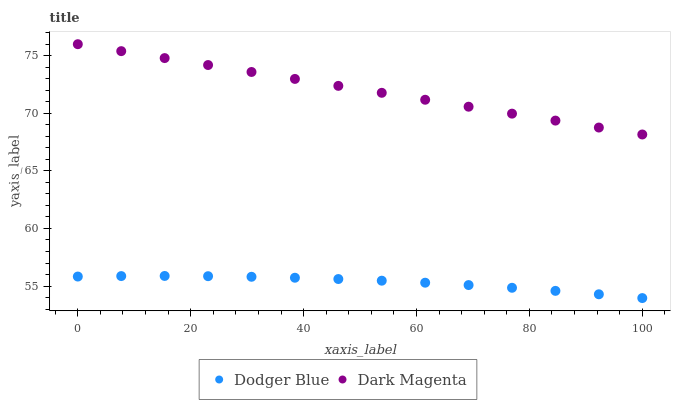Does Dodger Blue have the minimum area under the curve?
Answer yes or no. Yes. Does Dark Magenta have the maximum area under the curve?
Answer yes or no. Yes. Does Dark Magenta have the minimum area under the curve?
Answer yes or no. No. Is Dark Magenta the smoothest?
Answer yes or no. Yes. Is Dodger Blue the roughest?
Answer yes or no. Yes. Is Dark Magenta the roughest?
Answer yes or no. No. Does Dodger Blue have the lowest value?
Answer yes or no. Yes. Does Dark Magenta have the lowest value?
Answer yes or no. No. Does Dark Magenta have the highest value?
Answer yes or no. Yes. Is Dodger Blue less than Dark Magenta?
Answer yes or no. Yes. Is Dark Magenta greater than Dodger Blue?
Answer yes or no. Yes. Does Dodger Blue intersect Dark Magenta?
Answer yes or no. No. 